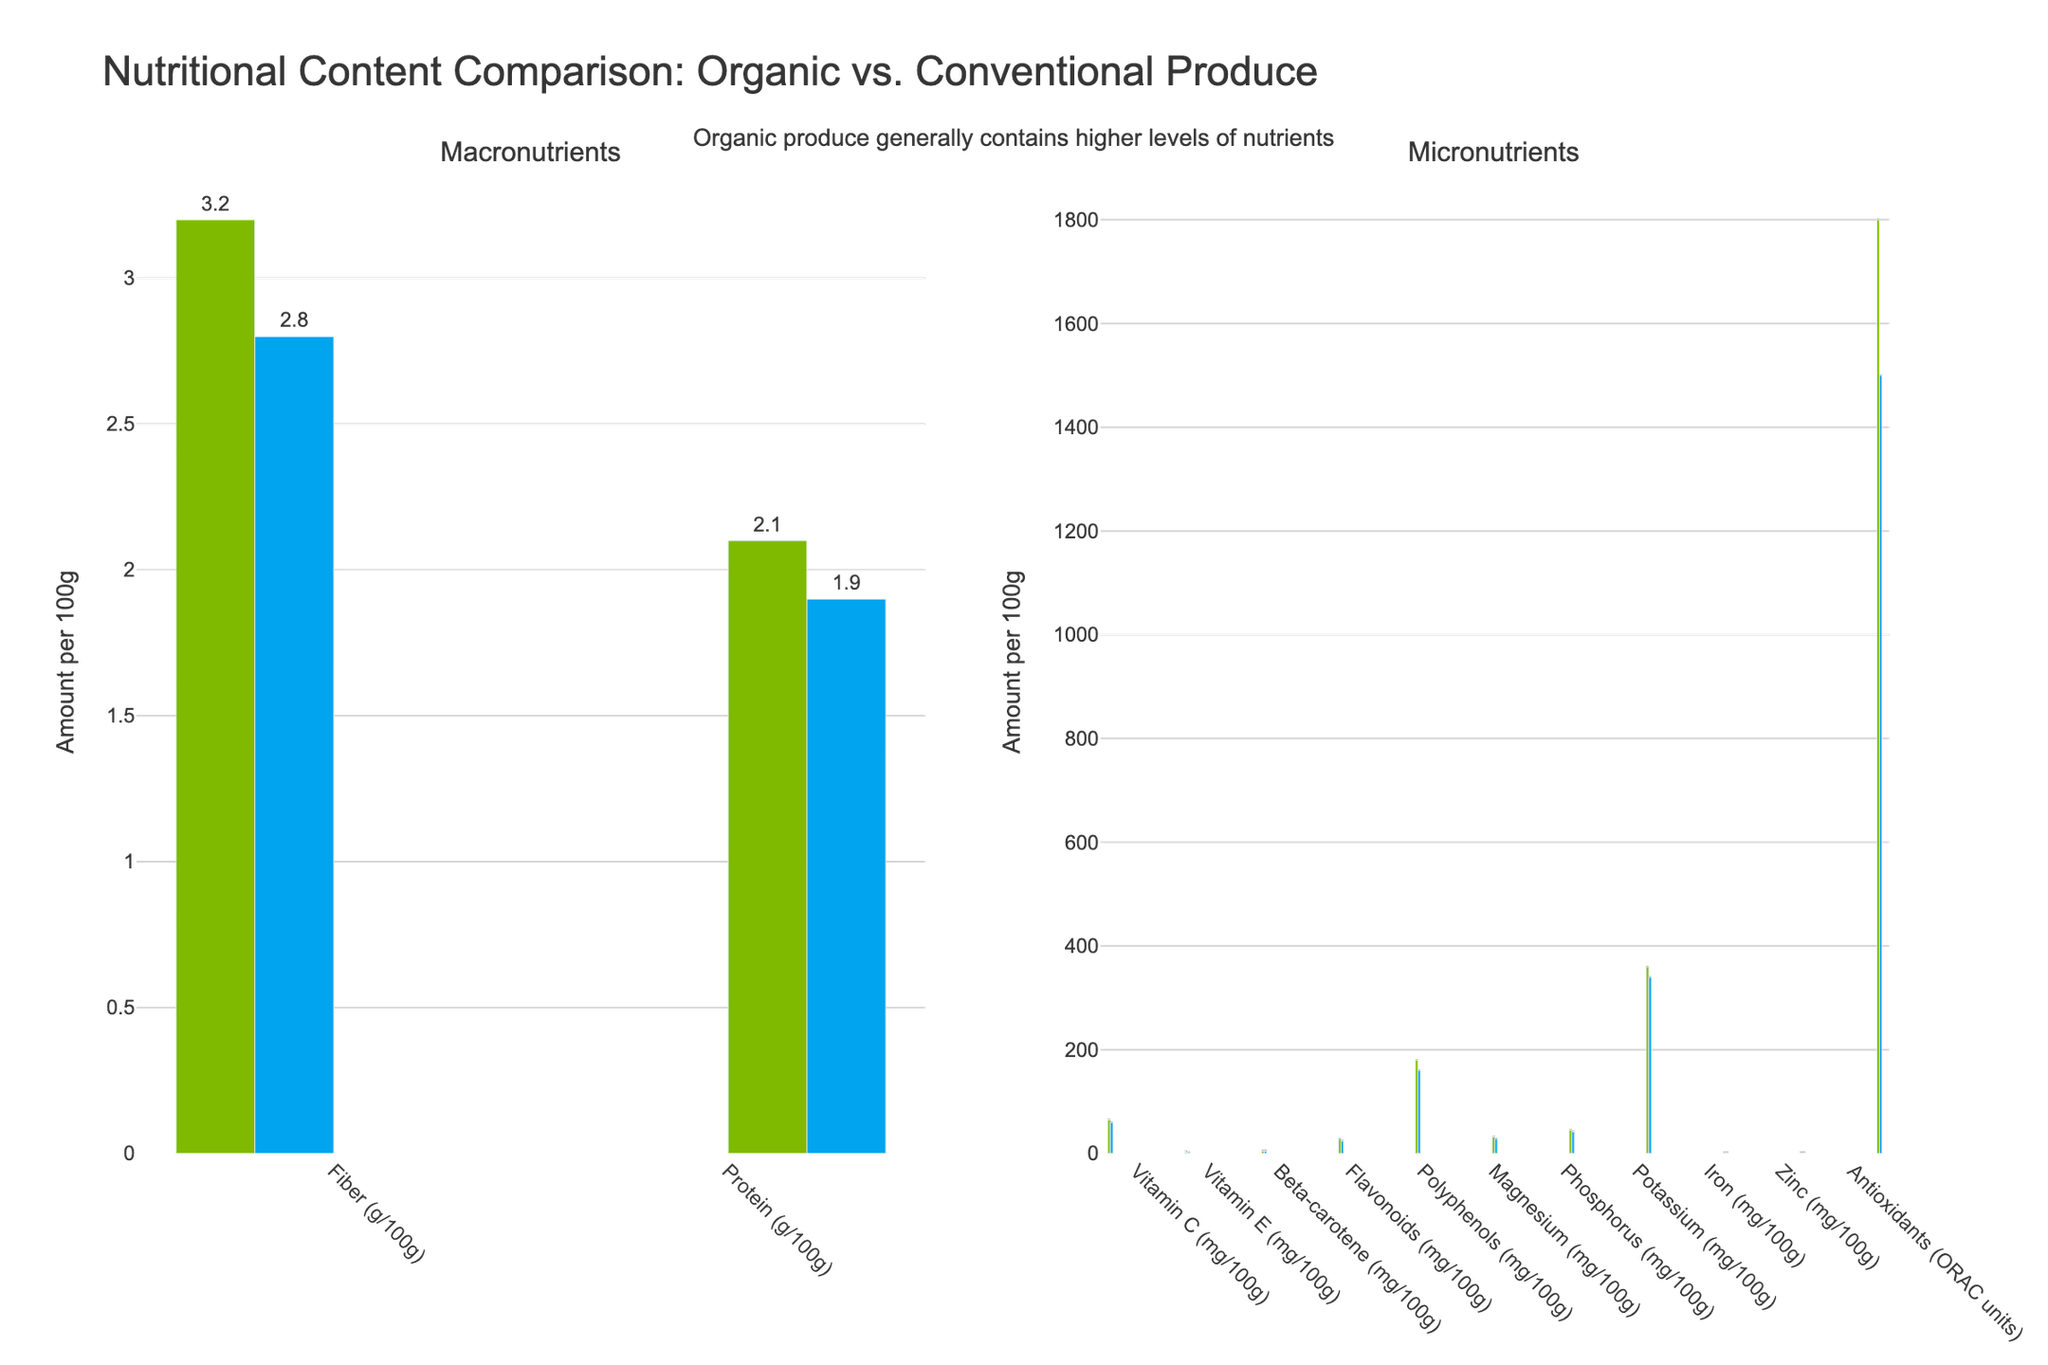How much more Vitamin C do organic produce contain compared to conventional produce? To find the amount more of Vitamin C in organic produce, subtract the Vitamin C content in conventional produce from that in organic produce: 65 - 60.
Answer: 5 mg Comparing the levels of antioxidants, which type of produce has higher values and by how much? First, note the antioxidant values for both types: Organic has 1800 and Conventional has 1500. Subtract the conventional value from the organic value to find the difference: 1800 - 1500.
Answer: Organic, by 300 ORAC units In terms of protein content, which type of produce has higher content and what is the difference? The protein content for organic produce is 2.1 g/100g and for conventional produce is 1.9 g/100g. Subtract the conventional value from the organic value to find the difference: 2.1 - 1.9.
Answer: Organic, by 0.2 g/100g Is there any nutrient where conventional produce contains more than organic produce? By checking the bar heights of each nutrient, we find that for all listed nutrients, organic produce has higher values than conventional produce.
Answer: No What's the average amount of Magnesium in both types of produce? Add the values of Magnesium for both types and divide by 2: (32 + 28) / 2.
Answer: 30 mg/100g How do the levels of Flavonoids compare between organic and conventional produce? The Flavonoid content for organic produce is 28 mg/100g and for conventional produce is 24 mg/100g. Subtract the conventional value from the organic value to find the difference: 28 - 24.
Answer: Organic, by 4 mg Which micronutrient has the smallest difference in content between organic and conventional produce? Subtract the conventional value from the organic value for each micronutrient and identify the smallest difference: Zinc has 0.4 - 0.3 = 0.1 mg/100g.
Answer: Zinc, 0.1 mg Does organic produce have more fiber or more protein compared to conventional produce? Compare the fiber difference and the protein difference between organic and conventional produce. Fiber difference: 3.2 - 2.8 = 0.4g, Protein difference: 2.1 - 1.9 = 0.2g.
Answer: More fiber What's the total amount of Potassium in 100g of both organic and conventional produce combined? Add the Potassium content for both types of produce: 360 + 340.
Answer: 700 mg/100g For which nutrient is the percentage increase the highest from conventional to organic produce? Calculate the percentage increase for each nutrient, using the formula: [(Organic - Conventional) / Conventional] * 100. Identify the highest percentage increase:
Vitamin C: (65-60) / 60 * 100 = 8.33%
Vitamin E: (1.8-1.5) / 1.5 * 100 = 20%
Beta-carotene: (4.2-3.8) / 3.8 * 100 = 10.53%
Flavonoids: (28-24) / 24 * 100 = 16.67%
Polyphenols: (180-160) / 160 * 100 = 12.5%
Magnesium: (32-28) / 28 * 100 = 14.29%
Phosphorus: (45-42) / 42 * 100 = 7.14%
Potassium: (360-340) / 340 * 100 = 5.88%
Iron: (1.2-1.0) / 1.0 * 100 = 20%
Zinc: (0.4-0.3) / 0.3 * 100 = 33.33%
Antioxidants: (1800-1500) / 1500 * 100 = 20%
Fiber: (3.2-2.8) / 2.8 * 100 = 14.29%
Protein: (2.1-1.9) / 1.9 * 100 = 10.53%
The highest percentage increase is for Zinc.
Answer: Zinc, 33.33% 